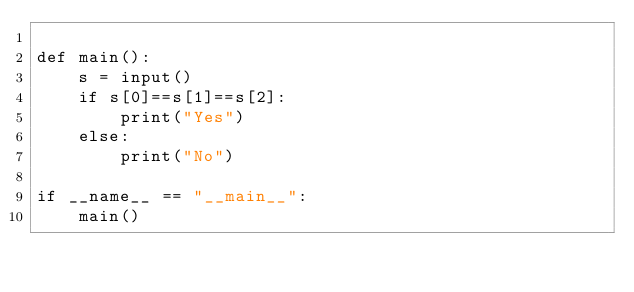<code> <loc_0><loc_0><loc_500><loc_500><_Python_>
def main():
    s = input()
    if s[0]==s[1]==s[2]:
        print("Yes")
    else:
        print("No")

if __name__ == "__main__":
    main()</code> 